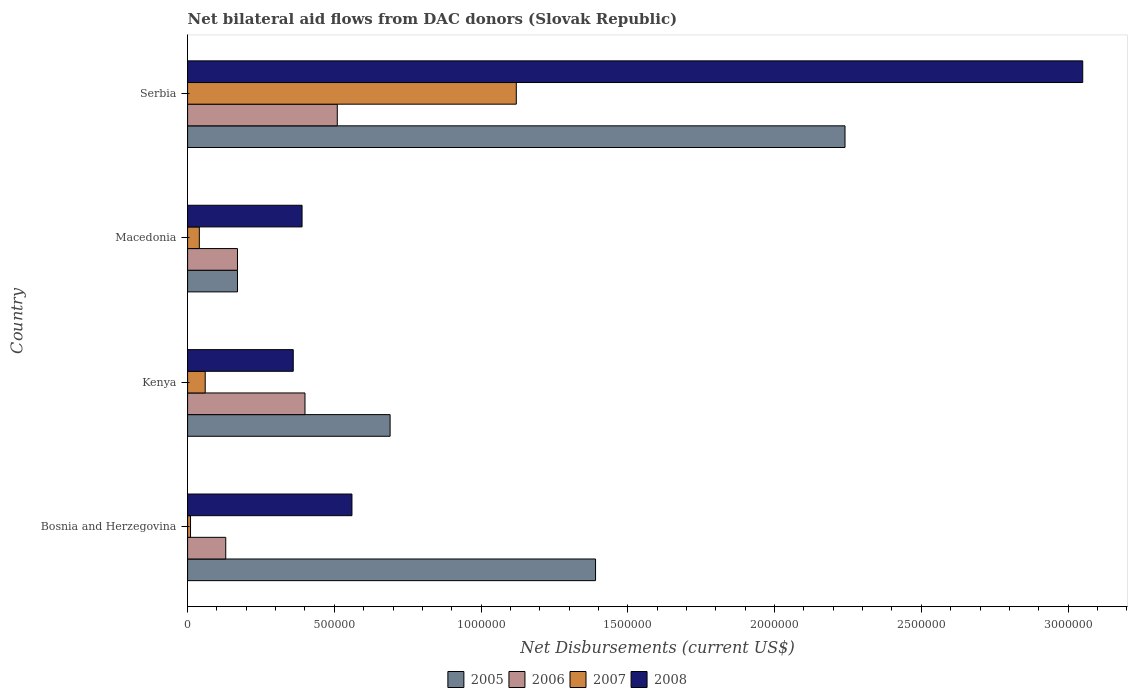How many groups of bars are there?
Offer a very short reply. 4. Are the number of bars on each tick of the Y-axis equal?
Provide a short and direct response. Yes. What is the label of the 2nd group of bars from the top?
Ensure brevity in your answer.  Macedonia. In how many cases, is the number of bars for a given country not equal to the number of legend labels?
Your response must be concise. 0. Across all countries, what is the maximum net bilateral aid flows in 2007?
Offer a terse response. 1.12e+06. In which country was the net bilateral aid flows in 2008 maximum?
Your response must be concise. Serbia. In which country was the net bilateral aid flows in 2008 minimum?
Make the answer very short. Kenya. What is the total net bilateral aid flows in 2007 in the graph?
Provide a succinct answer. 1.23e+06. What is the difference between the net bilateral aid flows in 2007 in Kenya and the net bilateral aid flows in 2008 in Macedonia?
Provide a succinct answer. -3.30e+05. What is the average net bilateral aid flows in 2005 per country?
Offer a terse response. 1.12e+06. What is the difference between the net bilateral aid flows in 2006 and net bilateral aid flows in 2008 in Bosnia and Herzegovina?
Your answer should be compact. -4.30e+05. What is the ratio of the net bilateral aid flows in 2006 in Bosnia and Herzegovina to that in Kenya?
Give a very brief answer. 0.33. Is the difference between the net bilateral aid flows in 2006 in Macedonia and Serbia greater than the difference between the net bilateral aid flows in 2008 in Macedonia and Serbia?
Your answer should be compact. Yes. What is the difference between the highest and the second highest net bilateral aid flows in 2007?
Keep it short and to the point. 1.06e+06. What is the difference between the highest and the lowest net bilateral aid flows in 2007?
Give a very brief answer. 1.11e+06. Is the sum of the net bilateral aid flows in 2008 in Kenya and Macedonia greater than the maximum net bilateral aid flows in 2005 across all countries?
Your response must be concise. No. What does the 1st bar from the top in Serbia represents?
Offer a terse response. 2008. How many bars are there?
Give a very brief answer. 16. Are all the bars in the graph horizontal?
Provide a short and direct response. Yes. Does the graph contain grids?
Your answer should be very brief. No. How many legend labels are there?
Provide a short and direct response. 4. How are the legend labels stacked?
Make the answer very short. Horizontal. What is the title of the graph?
Offer a very short reply. Net bilateral aid flows from DAC donors (Slovak Republic). Does "2001" appear as one of the legend labels in the graph?
Offer a terse response. No. What is the label or title of the X-axis?
Your answer should be compact. Net Disbursements (current US$). What is the label or title of the Y-axis?
Provide a short and direct response. Country. What is the Net Disbursements (current US$) in 2005 in Bosnia and Herzegovina?
Offer a very short reply. 1.39e+06. What is the Net Disbursements (current US$) of 2006 in Bosnia and Herzegovina?
Offer a very short reply. 1.30e+05. What is the Net Disbursements (current US$) in 2008 in Bosnia and Herzegovina?
Offer a very short reply. 5.60e+05. What is the Net Disbursements (current US$) in 2005 in Kenya?
Make the answer very short. 6.90e+05. What is the Net Disbursements (current US$) of 2007 in Kenya?
Keep it short and to the point. 6.00e+04. What is the Net Disbursements (current US$) in 2005 in Macedonia?
Ensure brevity in your answer.  1.70e+05. What is the Net Disbursements (current US$) in 2006 in Macedonia?
Offer a terse response. 1.70e+05. What is the Net Disbursements (current US$) of 2007 in Macedonia?
Give a very brief answer. 4.00e+04. What is the Net Disbursements (current US$) in 2008 in Macedonia?
Provide a short and direct response. 3.90e+05. What is the Net Disbursements (current US$) of 2005 in Serbia?
Provide a succinct answer. 2.24e+06. What is the Net Disbursements (current US$) of 2006 in Serbia?
Offer a terse response. 5.10e+05. What is the Net Disbursements (current US$) in 2007 in Serbia?
Provide a succinct answer. 1.12e+06. What is the Net Disbursements (current US$) in 2008 in Serbia?
Provide a succinct answer. 3.05e+06. Across all countries, what is the maximum Net Disbursements (current US$) in 2005?
Provide a succinct answer. 2.24e+06. Across all countries, what is the maximum Net Disbursements (current US$) of 2006?
Provide a succinct answer. 5.10e+05. Across all countries, what is the maximum Net Disbursements (current US$) in 2007?
Provide a short and direct response. 1.12e+06. Across all countries, what is the maximum Net Disbursements (current US$) of 2008?
Give a very brief answer. 3.05e+06. Across all countries, what is the minimum Net Disbursements (current US$) of 2006?
Offer a terse response. 1.30e+05. What is the total Net Disbursements (current US$) in 2005 in the graph?
Your response must be concise. 4.49e+06. What is the total Net Disbursements (current US$) in 2006 in the graph?
Your answer should be very brief. 1.21e+06. What is the total Net Disbursements (current US$) in 2007 in the graph?
Make the answer very short. 1.23e+06. What is the total Net Disbursements (current US$) in 2008 in the graph?
Offer a very short reply. 4.36e+06. What is the difference between the Net Disbursements (current US$) of 2007 in Bosnia and Herzegovina and that in Kenya?
Make the answer very short. -5.00e+04. What is the difference between the Net Disbursements (current US$) in 2008 in Bosnia and Herzegovina and that in Kenya?
Offer a terse response. 2.00e+05. What is the difference between the Net Disbursements (current US$) of 2005 in Bosnia and Herzegovina and that in Macedonia?
Your answer should be very brief. 1.22e+06. What is the difference between the Net Disbursements (current US$) of 2006 in Bosnia and Herzegovina and that in Macedonia?
Offer a terse response. -4.00e+04. What is the difference between the Net Disbursements (current US$) of 2007 in Bosnia and Herzegovina and that in Macedonia?
Keep it short and to the point. -3.00e+04. What is the difference between the Net Disbursements (current US$) of 2008 in Bosnia and Herzegovina and that in Macedonia?
Provide a short and direct response. 1.70e+05. What is the difference between the Net Disbursements (current US$) of 2005 in Bosnia and Herzegovina and that in Serbia?
Your answer should be very brief. -8.50e+05. What is the difference between the Net Disbursements (current US$) in 2006 in Bosnia and Herzegovina and that in Serbia?
Your response must be concise. -3.80e+05. What is the difference between the Net Disbursements (current US$) of 2007 in Bosnia and Herzegovina and that in Serbia?
Give a very brief answer. -1.11e+06. What is the difference between the Net Disbursements (current US$) of 2008 in Bosnia and Herzegovina and that in Serbia?
Keep it short and to the point. -2.49e+06. What is the difference between the Net Disbursements (current US$) in 2005 in Kenya and that in Macedonia?
Make the answer very short. 5.20e+05. What is the difference between the Net Disbursements (current US$) in 2007 in Kenya and that in Macedonia?
Ensure brevity in your answer.  2.00e+04. What is the difference between the Net Disbursements (current US$) of 2008 in Kenya and that in Macedonia?
Offer a terse response. -3.00e+04. What is the difference between the Net Disbursements (current US$) of 2005 in Kenya and that in Serbia?
Provide a succinct answer. -1.55e+06. What is the difference between the Net Disbursements (current US$) in 2007 in Kenya and that in Serbia?
Ensure brevity in your answer.  -1.06e+06. What is the difference between the Net Disbursements (current US$) of 2008 in Kenya and that in Serbia?
Offer a terse response. -2.69e+06. What is the difference between the Net Disbursements (current US$) in 2005 in Macedonia and that in Serbia?
Make the answer very short. -2.07e+06. What is the difference between the Net Disbursements (current US$) in 2006 in Macedonia and that in Serbia?
Make the answer very short. -3.40e+05. What is the difference between the Net Disbursements (current US$) in 2007 in Macedonia and that in Serbia?
Provide a succinct answer. -1.08e+06. What is the difference between the Net Disbursements (current US$) in 2008 in Macedonia and that in Serbia?
Offer a very short reply. -2.66e+06. What is the difference between the Net Disbursements (current US$) of 2005 in Bosnia and Herzegovina and the Net Disbursements (current US$) of 2006 in Kenya?
Keep it short and to the point. 9.90e+05. What is the difference between the Net Disbursements (current US$) in 2005 in Bosnia and Herzegovina and the Net Disbursements (current US$) in 2007 in Kenya?
Offer a very short reply. 1.33e+06. What is the difference between the Net Disbursements (current US$) of 2005 in Bosnia and Herzegovina and the Net Disbursements (current US$) of 2008 in Kenya?
Make the answer very short. 1.03e+06. What is the difference between the Net Disbursements (current US$) in 2006 in Bosnia and Herzegovina and the Net Disbursements (current US$) in 2007 in Kenya?
Ensure brevity in your answer.  7.00e+04. What is the difference between the Net Disbursements (current US$) in 2006 in Bosnia and Herzegovina and the Net Disbursements (current US$) in 2008 in Kenya?
Your answer should be compact. -2.30e+05. What is the difference between the Net Disbursements (current US$) of 2007 in Bosnia and Herzegovina and the Net Disbursements (current US$) of 2008 in Kenya?
Your response must be concise. -3.50e+05. What is the difference between the Net Disbursements (current US$) in 2005 in Bosnia and Herzegovina and the Net Disbursements (current US$) in 2006 in Macedonia?
Make the answer very short. 1.22e+06. What is the difference between the Net Disbursements (current US$) in 2005 in Bosnia and Herzegovina and the Net Disbursements (current US$) in 2007 in Macedonia?
Your answer should be compact. 1.35e+06. What is the difference between the Net Disbursements (current US$) in 2005 in Bosnia and Herzegovina and the Net Disbursements (current US$) in 2008 in Macedonia?
Provide a succinct answer. 1.00e+06. What is the difference between the Net Disbursements (current US$) in 2006 in Bosnia and Herzegovina and the Net Disbursements (current US$) in 2008 in Macedonia?
Your response must be concise. -2.60e+05. What is the difference between the Net Disbursements (current US$) in 2007 in Bosnia and Herzegovina and the Net Disbursements (current US$) in 2008 in Macedonia?
Provide a short and direct response. -3.80e+05. What is the difference between the Net Disbursements (current US$) in 2005 in Bosnia and Herzegovina and the Net Disbursements (current US$) in 2006 in Serbia?
Offer a very short reply. 8.80e+05. What is the difference between the Net Disbursements (current US$) of 2005 in Bosnia and Herzegovina and the Net Disbursements (current US$) of 2007 in Serbia?
Provide a short and direct response. 2.70e+05. What is the difference between the Net Disbursements (current US$) in 2005 in Bosnia and Herzegovina and the Net Disbursements (current US$) in 2008 in Serbia?
Provide a short and direct response. -1.66e+06. What is the difference between the Net Disbursements (current US$) in 2006 in Bosnia and Herzegovina and the Net Disbursements (current US$) in 2007 in Serbia?
Offer a terse response. -9.90e+05. What is the difference between the Net Disbursements (current US$) in 2006 in Bosnia and Herzegovina and the Net Disbursements (current US$) in 2008 in Serbia?
Your response must be concise. -2.92e+06. What is the difference between the Net Disbursements (current US$) of 2007 in Bosnia and Herzegovina and the Net Disbursements (current US$) of 2008 in Serbia?
Provide a short and direct response. -3.04e+06. What is the difference between the Net Disbursements (current US$) of 2005 in Kenya and the Net Disbursements (current US$) of 2006 in Macedonia?
Provide a short and direct response. 5.20e+05. What is the difference between the Net Disbursements (current US$) of 2005 in Kenya and the Net Disbursements (current US$) of 2007 in Macedonia?
Offer a very short reply. 6.50e+05. What is the difference between the Net Disbursements (current US$) of 2006 in Kenya and the Net Disbursements (current US$) of 2007 in Macedonia?
Give a very brief answer. 3.60e+05. What is the difference between the Net Disbursements (current US$) of 2007 in Kenya and the Net Disbursements (current US$) of 2008 in Macedonia?
Your answer should be compact. -3.30e+05. What is the difference between the Net Disbursements (current US$) of 2005 in Kenya and the Net Disbursements (current US$) of 2007 in Serbia?
Make the answer very short. -4.30e+05. What is the difference between the Net Disbursements (current US$) in 2005 in Kenya and the Net Disbursements (current US$) in 2008 in Serbia?
Your response must be concise. -2.36e+06. What is the difference between the Net Disbursements (current US$) in 2006 in Kenya and the Net Disbursements (current US$) in 2007 in Serbia?
Your answer should be compact. -7.20e+05. What is the difference between the Net Disbursements (current US$) of 2006 in Kenya and the Net Disbursements (current US$) of 2008 in Serbia?
Provide a short and direct response. -2.65e+06. What is the difference between the Net Disbursements (current US$) in 2007 in Kenya and the Net Disbursements (current US$) in 2008 in Serbia?
Give a very brief answer. -2.99e+06. What is the difference between the Net Disbursements (current US$) in 2005 in Macedonia and the Net Disbursements (current US$) in 2006 in Serbia?
Your answer should be very brief. -3.40e+05. What is the difference between the Net Disbursements (current US$) of 2005 in Macedonia and the Net Disbursements (current US$) of 2007 in Serbia?
Ensure brevity in your answer.  -9.50e+05. What is the difference between the Net Disbursements (current US$) in 2005 in Macedonia and the Net Disbursements (current US$) in 2008 in Serbia?
Your answer should be very brief. -2.88e+06. What is the difference between the Net Disbursements (current US$) in 2006 in Macedonia and the Net Disbursements (current US$) in 2007 in Serbia?
Provide a short and direct response. -9.50e+05. What is the difference between the Net Disbursements (current US$) of 2006 in Macedonia and the Net Disbursements (current US$) of 2008 in Serbia?
Make the answer very short. -2.88e+06. What is the difference between the Net Disbursements (current US$) in 2007 in Macedonia and the Net Disbursements (current US$) in 2008 in Serbia?
Provide a succinct answer. -3.01e+06. What is the average Net Disbursements (current US$) in 2005 per country?
Give a very brief answer. 1.12e+06. What is the average Net Disbursements (current US$) in 2006 per country?
Keep it short and to the point. 3.02e+05. What is the average Net Disbursements (current US$) of 2007 per country?
Your answer should be very brief. 3.08e+05. What is the average Net Disbursements (current US$) in 2008 per country?
Your response must be concise. 1.09e+06. What is the difference between the Net Disbursements (current US$) in 2005 and Net Disbursements (current US$) in 2006 in Bosnia and Herzegovina?
Provide a succinct answer. 1.26e+06. What is the difference between the Net Disbursements (current US$) in 2005 and Net Disbursements (current US$) in 2007 in Bosnia and Herzegovina?
Ensure brevity in your answer.  1.38e+06. What is the difference between the Net Disbursements (current US$) of 2005 and Net Disbursements (current US$) of 2008 in Bosnia and Herzegovina?
Keep it short and to the point. 8.30e+05. What is the difference between the Net Disbursements (current US$) of 2006 and Net Disbursements (current US$) of 2007 in Bosnia and Herzegovina?
Your answer should be compact. 1.20e+05. What is the difference between the Net Disbursements (current US$) in 2006 and Net Disbursements (current US$) in 2008 in Bosnia and Herzegovina?
Provide a succinct answer. -4.30e+05. What is the difference between the Net Disbursements (current US$) of 2007 and Net Disbursements (current US$) of 2008 in Bosnia and Herzegovina?
Keep it short and to the point. -5.50e+05. What is the difference between the Net Disbursements (current US$) in 2005 and Net Disbursements (current US$) in 2007 in Kenya?
Give a very brief answer. 6.30e+05. What is the difference between the Net Disbursements (current US$) of 2005 and Net Disbursements (current US$) of 2007 in Macedonia?
Keep it short and to the point. 1.30e+05. What is the difference between the Net Disbursements (current US$) in 2005 and Net Disbursements (current US$) in 2008 in Macedonia?
Give a very brief answer. -2.20e+05. What is the difference between the Net Disbursements (current US$) in 2006 and Net Disbursements (current US$) in 2007 in Macedonia?
Your answer should be compact. 1.30e+05. What is the difference between the Net Disbursements (current US$) in 2006 and Net Disbursements (current US$) in 2008 in Macedonia?
Your answer should be very brief. -2.20e+05. What is the difference between the Net Disbursements (current US$) in 2007 and Net Disbursements (current US$) in 2008 in Macedonia?
Your answer should be compact. -3.50e+05. What is the difference between the Net Disbursements (current US$) in 2005 and Net Disbursements (current US$) in 2006 in Serbia?
Ensure brevity in your answer.  1.73e+06. What is the difference between the Net Disbursements (current US$) of 2005 and Net Disbursements (current US$) of 2007 in Serbia?
Offer a terse response. 1.12e+06. What is the difference between the Net Disbursements (current US$) in 2005 and Net Disbursements (current US$) in 2008 in Serbia?
Offer a terse response. -8.10e+05. What is the difference between the Net Disbursements (current US$) of 2006 and Net Disbursements (current US$) of 2007 in Serbia?
Offer a very short reply. -6.10e+05. What is the difference between the Net Disbursements (current US$) in 2006 and Net Disbursements (current US$) in 2008 in Serbia?
Offer a terse response. -2.54e+06. What is the difference between the Net Disbursements (current US$) of 2007 and Net Disbursements (current US$) of 2008 in Serbia?
Your answer should be very brief. -1.93e+06. What is the ratio of the Net Disbursements (current US$) of 2005 in Bosnia and Herzegovina to that in Kenya?
Ensure brevity in your answer.  2.01. What is the ratio of the Net Disbursements (current US$) in 2006 in Bosnia and Herzegovina to that in Kenya?
Your answer should be very brief. 0.33. What is the ratio of the Net Disbursements (current US$) in 2007 in Bosnia and Herzegovina to that in Kenya?
Offer a very short reply. 0.17. What is the ratio of the Net Disbursements (current US$) in 2008 in Bosnia and Herzegovina to that in Kenya?
Give a very brief answer. 1.56. What is the ratio of the Net Disbursements (current US$) in 2005 in Bosnia and Herzegovina to that in Macedonia?
Ensure brevity in your answer.  8.18. What is the ratio of the Net Disbursements (current US$) in 2006 in Bosnia and Herzegovina to that in Macedonia?
Your response must be concise. 0.76. What is the ratio of the Net Disbursements (current US$) in 2008 in Bosnia and Herzegovina to that in Macedonia?
Make the answer very short. 1.44. What is the ratio of the Net Disbursements (current US$) in 2005 in Bosnia and Herzegovina to that in Serbia?
Your response must be concise. 0.62. What is the ratio of the Net Disbursements (current US$) of 2006 in Bosnia and Herzegovina to that in Serbia?
Give a very brief answer. 0.25. What is the ratio of the Net Disbursements (current US$) of 2007 in Bosnia and Herzegovina to that in Serbia?
Keep it short and to the point. 0.01. What is the ratio of the Net Disbursements (current US$) in 2008 in Bosnia and Herzegovina to that in Serbia?
Your response must be concise. 0.18. What is the ratio of the Net Disbursements (current US$) of 2005 in Kenya to that in Macedonia?
Give a very brief answer. 4.06. What is the ratio of the Net Disbursements (current US$) in 2006 in Kenya to that in Macedonia?
Your answer should be very brief. 2.35. What is the ratio of the Net Disbursements (current US$) of 2008 in Kenya to that in Macedonia?
Ensure brevity in your answer.  0.92. What is the ratio of the Net Disbursements (current US$) in 2005 in Kenya to that in Serbia?
Your answer should be compact. 0.31. What is the ratio of the Net Disbursements (current US$) in 2006 in Kenya to that in Serbia?
Give a very brief answer. 0.78. What is the ratio of the Net Disbursements (current US$) in 2007 in Kenya to that in Serbia?
Provide a short and direct response. 0.05. What is the ratio of the Net Disbursements (current US$) of 2008 in Kenya to that in Serbia?
Your response must be concise. 0.12. What is the ratio of the Net Disbursements (current US$) of 2005 in Macedonia to that in Serbia?
Ensure brevity in your answer.  0.08. What is the ratio of the Net Disbursements (current US$) of 2006 in Macedonia to that in Serbia?
Your answer should be compact. 0.33. What is the ratio of the Net Disbursements (current US$) in 2007 in Macedonia to that in Serbia?
Ensure brevity in your answer.  0.04. What is the ratio of the Net Disbursements (current US$) of 2008 in Macedonia to that in Serbia?
Keep it short and to the point. 0.13. What is the difference between the highest and the second highest Net Disbursements (current US$) of 2005?
Your response must be concise. 8.50e+05. What is the difference between the highest and the second highest Net Disbursements (current US$) of 2006?
Provide a succinct answer. 1.10e+05. What is the difference between the highest and the second highest Net Disbursements (current US$) of 2007?
Provide a succinct answer. 1.06e+06. What is the difference between the highest and the second highest Net Disbursements (current US$) of 2008?
Offer a terse response. 2.49e+06. What is the difference between the highest and the lowest Net Disbursements (current US$) of 2005?
Offer a very short reply. 2.07e+06. What is the difference between the highest and the lowest Net Disbursements (current US$) in 2006?
Keep it short and to the point. 3.80e+05. What is the difference between the highest and the lowest Net Disbursements (current US$) in 2007?
Offer a very short reply. 1.11e+06. What is the difference between the highest and the lowest Net Disbursements (current US$) of 2008?
Make the answer very short. 2.69e+06. 